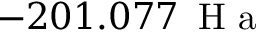Convert formula to latex. <formula><loc_0><loc_0><loc_500><loc_500>- 2 0 1 . 0 7 7 \, H a</formula> 